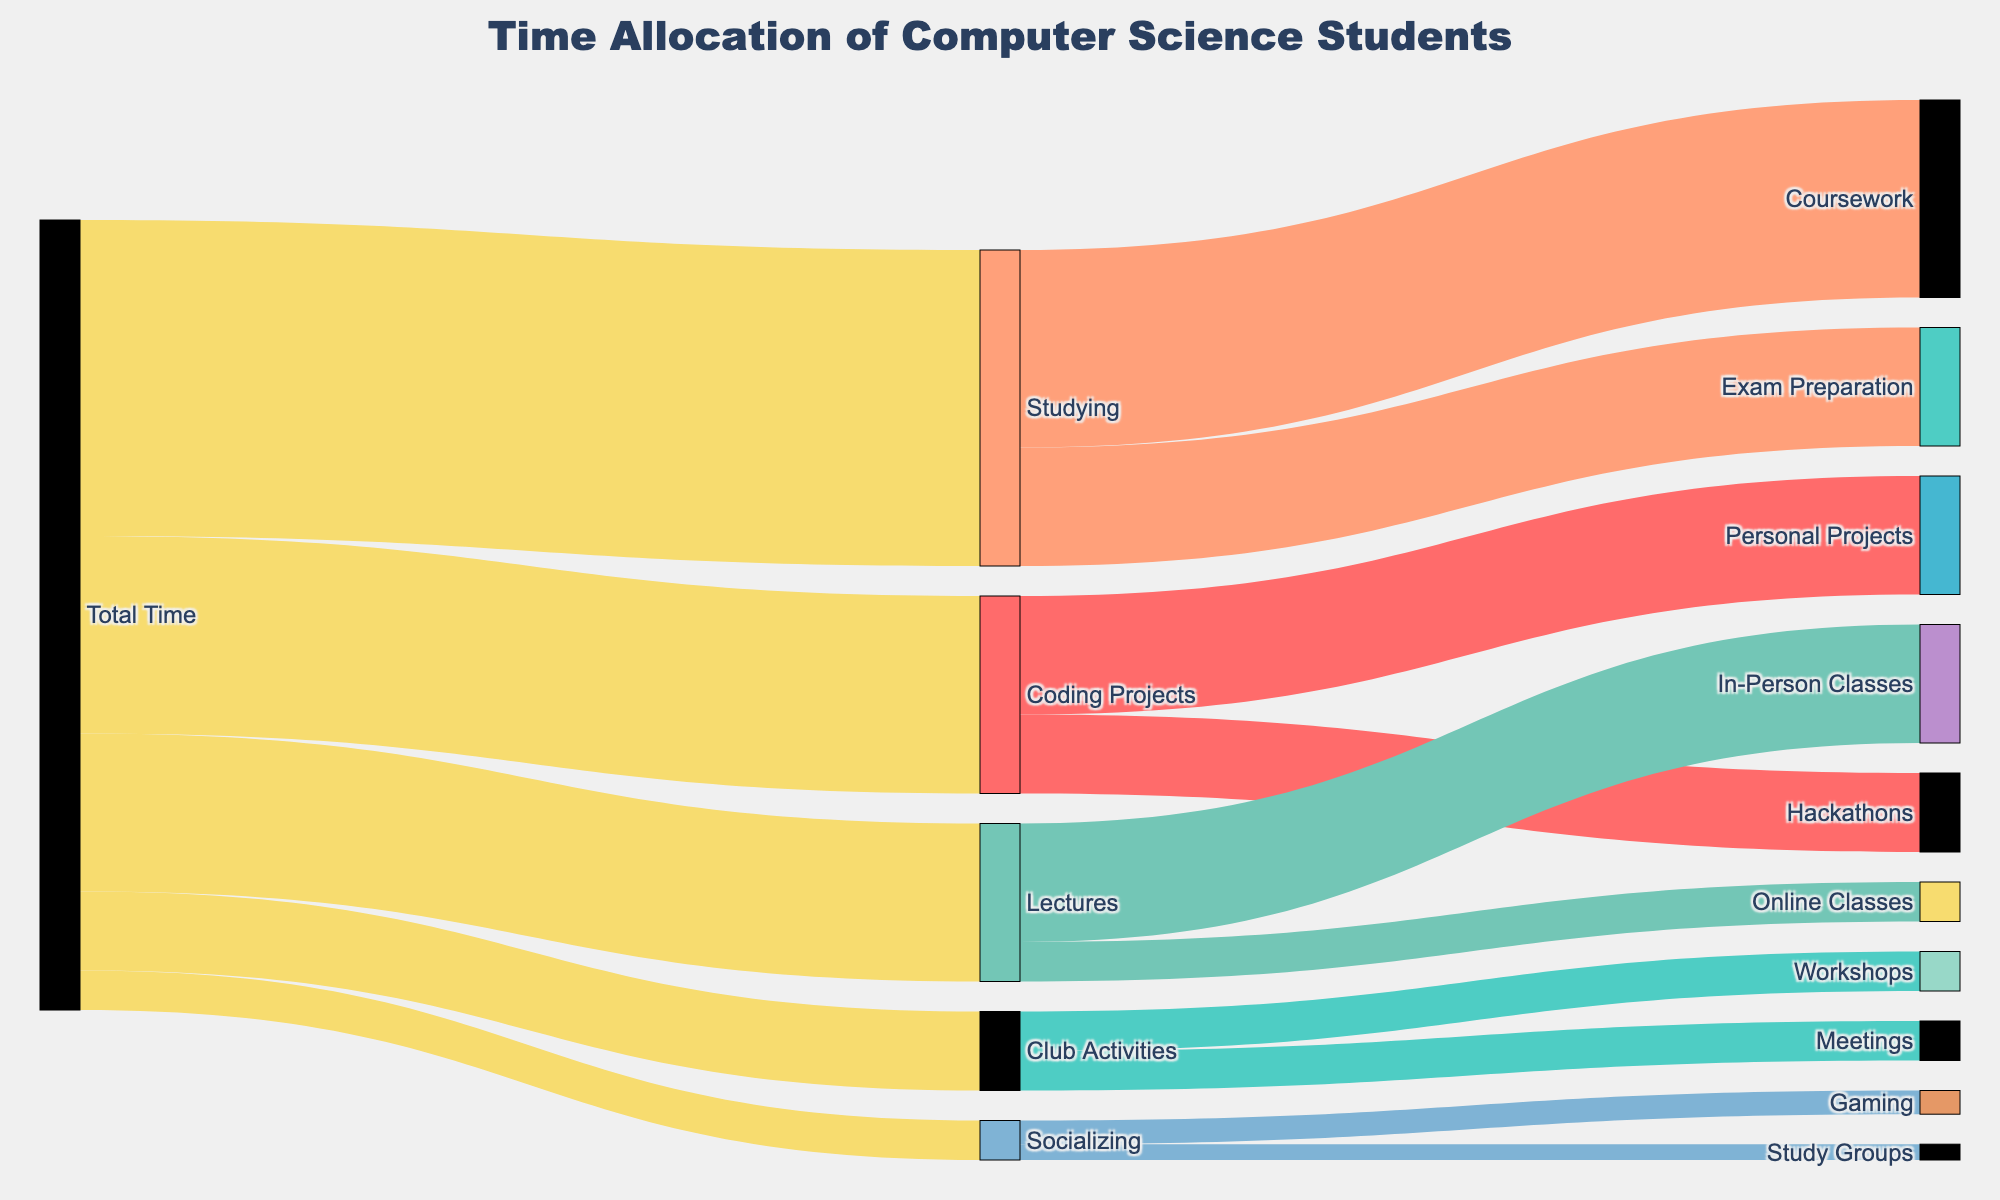What is the title of the figure? The title is displayed at the top center of the figure and helps identify what the entire Sankey diagram represents.
Answer: Time Allocation of Computer Science Students Which activity receives the most allocation of time from 'Studying'? Looking at the links from 'Studying,' we see the largest flow goes to 'Coursework' with a value of 25.
Answer: Coursework How much time in total is allocated to 'Studying' and 'Coding Projects'? To find the total time allocated to 'Studying' and 'Coding Projects,' we add their respective values: 40 (Studying) + 25 (Coding Projects) = 65.
Answer: 65 Which has higher time allocation: 'Lectures' or 'Club Activities'? By how much? Compare the values: Lectures (20) and Club Activities (10). Lectures have a higher allocation by 20 - 10 = 10.
Answer: Lectures by 10 How does time spent on 'Hackathons' compare to 'Exam Preparation'? We look at the links from 'Coding Projects' and 'Studying' respectively. Hackathons receive 10, and Exam Preparation receives 15. Therefore, Exam Preparation has more time allocated.
Answer: Exam Preparation gets more time What percentage of total time is spent on 'Personal Projects'? Calculate the percentage by dividing the time for 'Personal Projects' (15) by the 'Total Time' (100), and then multiply by 100. (15 / 100) * 100 = 15%.
Answer: 15% What is the total time spent on Socializing activities? Add the values of all targets under 'Socializing': Gaming (3) and Study Groups (2). This gives us 3 + 2 = 5.
Answer: 5 Out of the total time allocated to 'Lectures,' how much is spent on 'Online Classes'? From the links under 'Lectures,' 'Online Classes' receive 5 out of 20. To find the percentage: (5/20) * 100 = 25%.
Answer: 25% Which activity under 'Club Activities' has equal allocation? Both 'Workshops' and 'Meetings' receive an equal amount of time, which is 5 each.
Answer: Workshops and Meetings How does the time spent on 'Coding Projects' compare to 'Socializing'? By comparing their total values, 25 for 'Coding Projects' and 5 for 'Socializing', 'Coding Projects' have 20 more time units.
Answer: Coding Projects by 20 